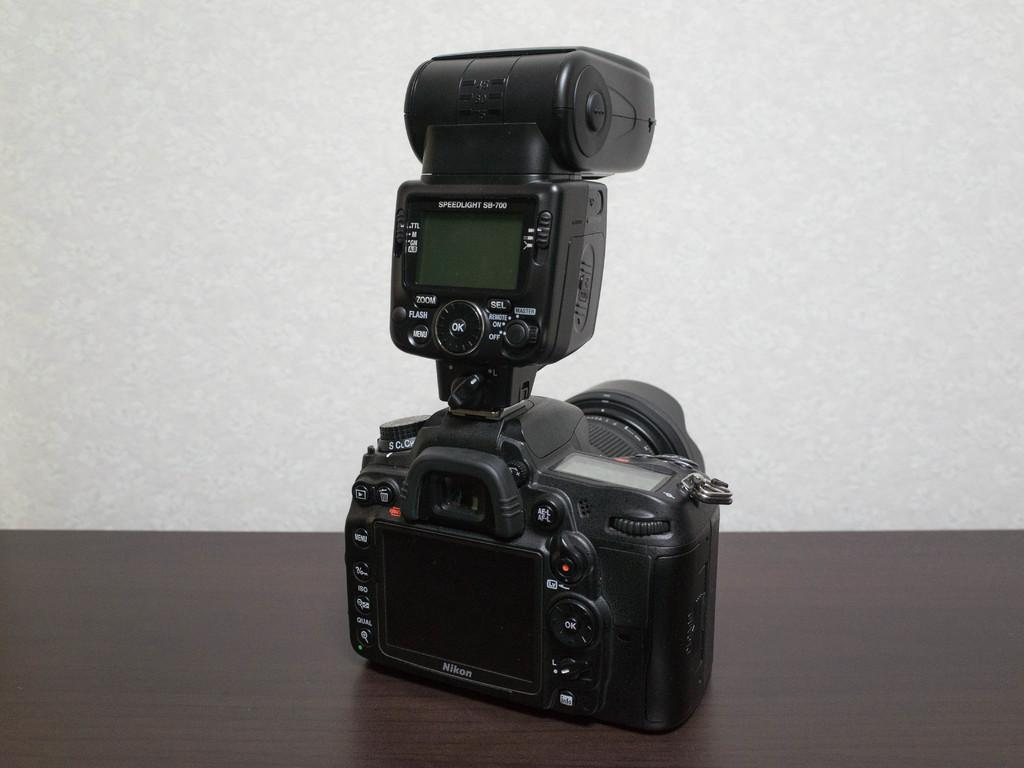What object is the main subject of the image? There is a digital camera in the image. What is the color of the digital camera? The camera is black in color. On what surface is the camera placed? The camera is placed on a brown surface. What can be seen in the background of the image? There is a wall in the background of the image. How many glasses are placed on the camera in the image? There are no glasses present in the image; the main subject is a digital camera placed on a brown surface. 